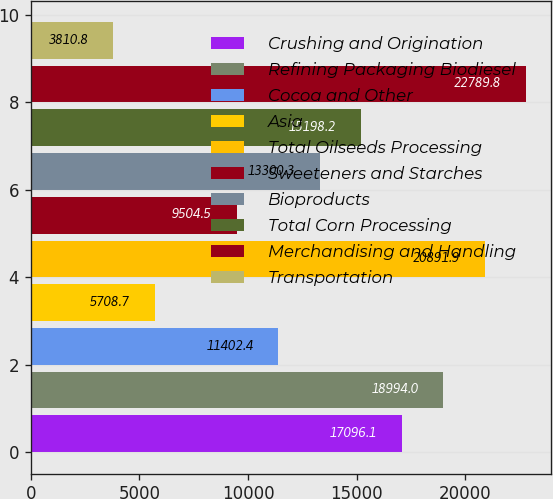Convert chart. <chart><loc_0><loc_0><loc_500><loc_500><bar_chart><fcel>Crushing and Origination<fcel>Refining Packaging Biodiesel<fcel>Cocoa and Other<fcel>Asia<fcel>Total Oilseeds Processing<fcel>Sweeteners and Starches<fcel>Bioproducts<fcel>Total Corn Processing<fcel>Merchandising and Handling<fcel>Transportation<nl><fcel>17096.1<fcel>18994<fcel>11402.4<fcel>5708.7<fcel>20891.9<fcel>9504.5<fcel>13300.3<fcel>15198.2<fcel>22789.8<fcel>3810.8<nl></chart> 